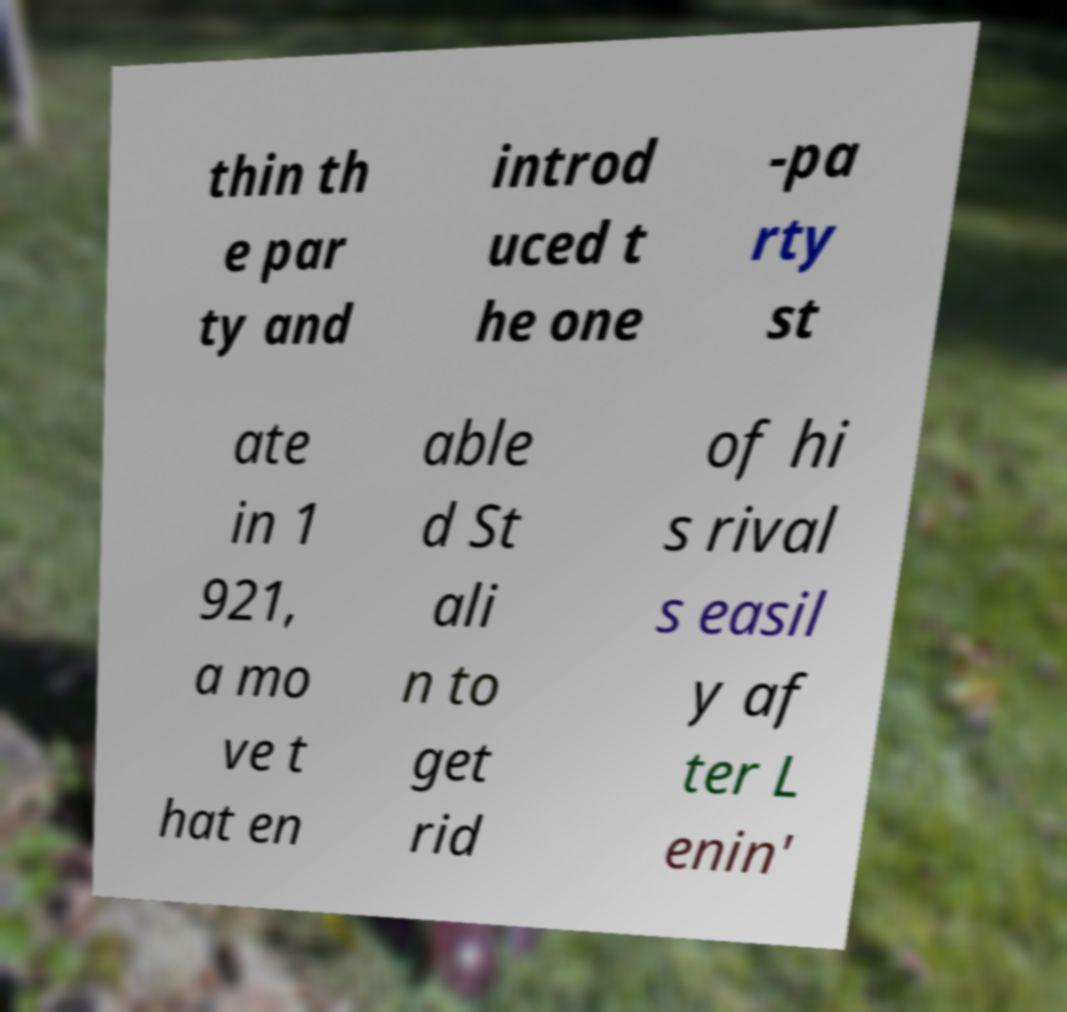Can you accurately transcribe the text from the provided image for me? thin th e par ty and introd uced t he one -pa rty st ate in 1 921, a mo ve t hat en able d St ali n to get rid of hi s rival s easil y af ter L enin' 